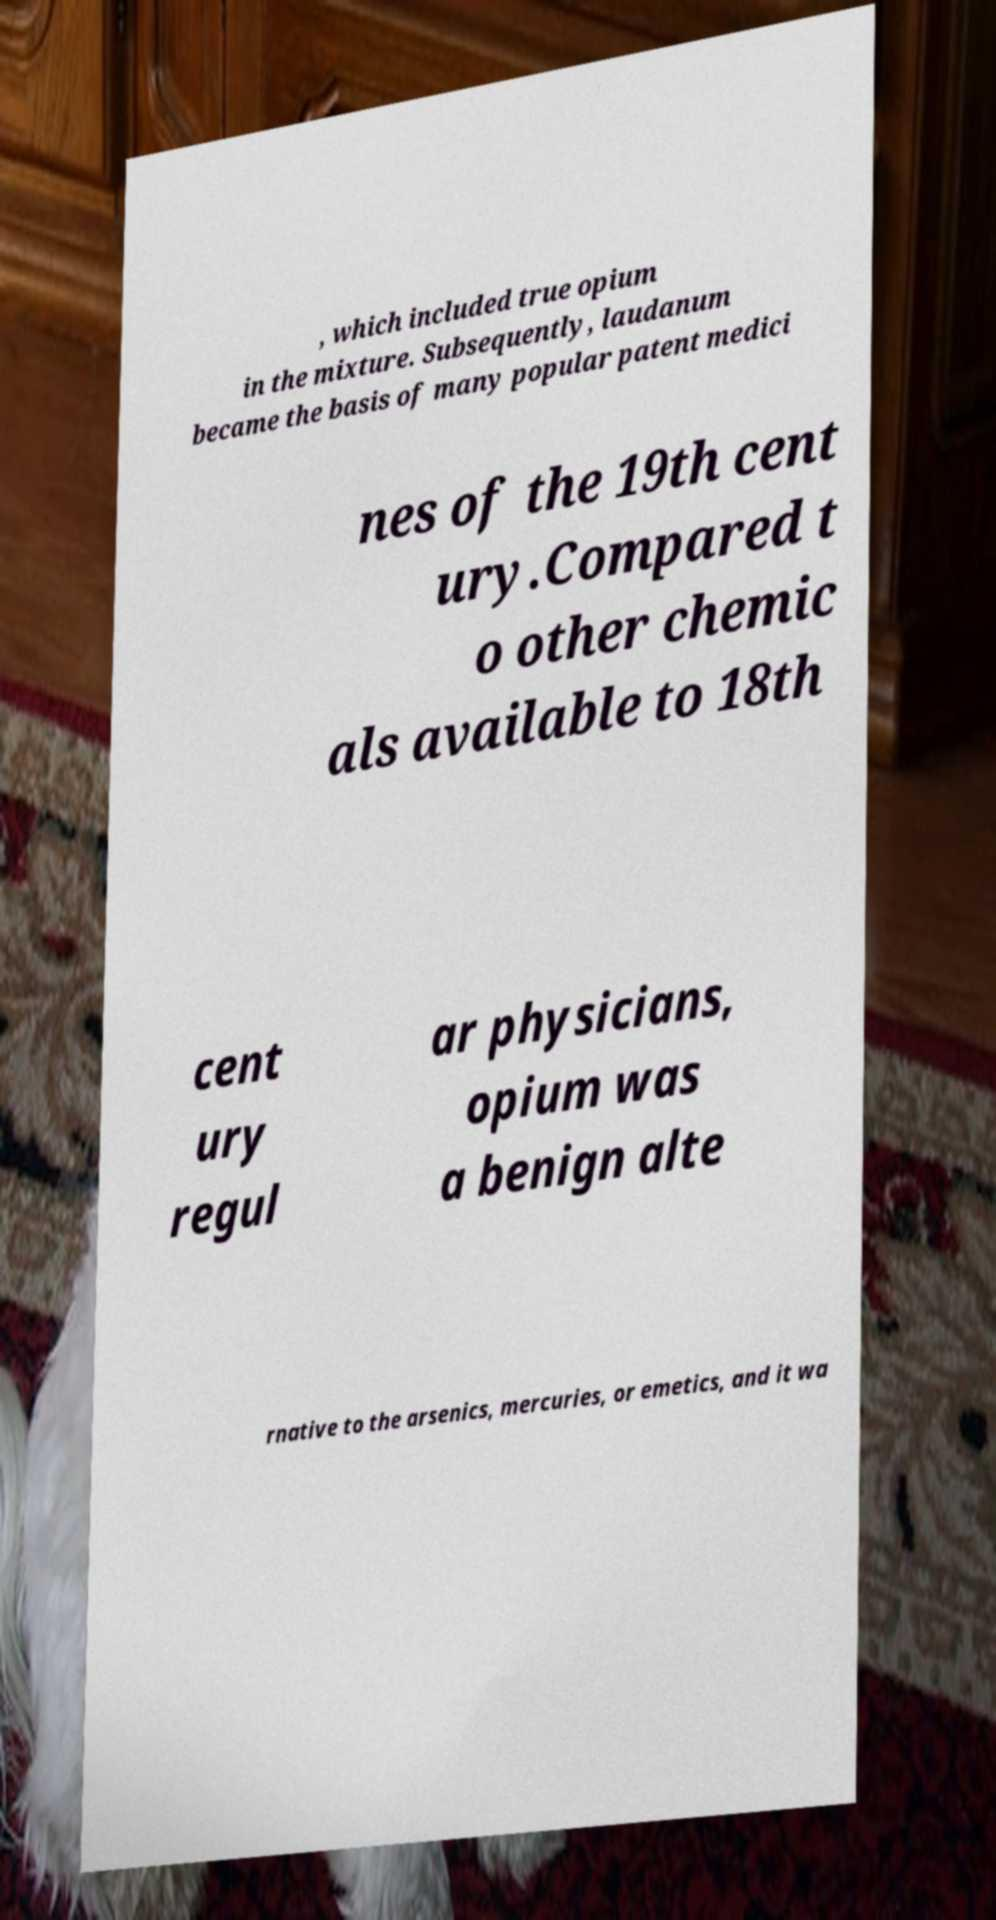Could you extract and type out the text from this image? , which included true opium in the mixture. Subsequently, laudanum became the basis of many popular patent medici nes of the 19th cent ury.Compared t o other chemic als available to 18th cent ury regul ar physicians, opium was a benign alte rnative to the arsenics, mercuries, or emetics, and it wa 